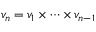<formula> <loc_0><loc_0><loc_500><loc_500>v _ { n } = v _ { 1 } \times \cdots \times v _ { n - 1 }</formula> 